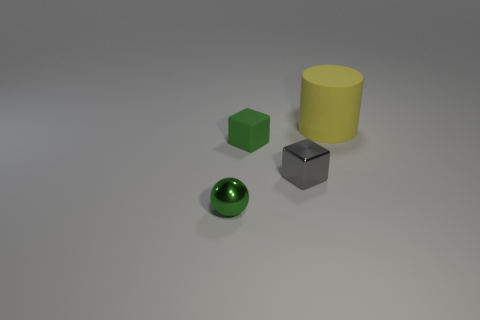Subtract all spheres. How many objects are left? 3 Subtract 1 spheres. How many spheres are left? 0 Subtract all brown spheres. Subtract all yellow blocks. How many spheres are left? 1 Subtract all purple cylinders. How many gray cubes are left? 1 Subtract all small red metallic cubes. Subtract all green rubber objects. How many objects are left? 3 Add 4 big things. How many big things are left? 5 Add 4 large gray shiny things. How many large gray shiny things exist? 4 Add 2 yellow rubber objects. How many objects exist? 6 Subtract all gray blocks. How many blocks are left? 1 Subtract 0 gray spheres. How many objects are left? 4 